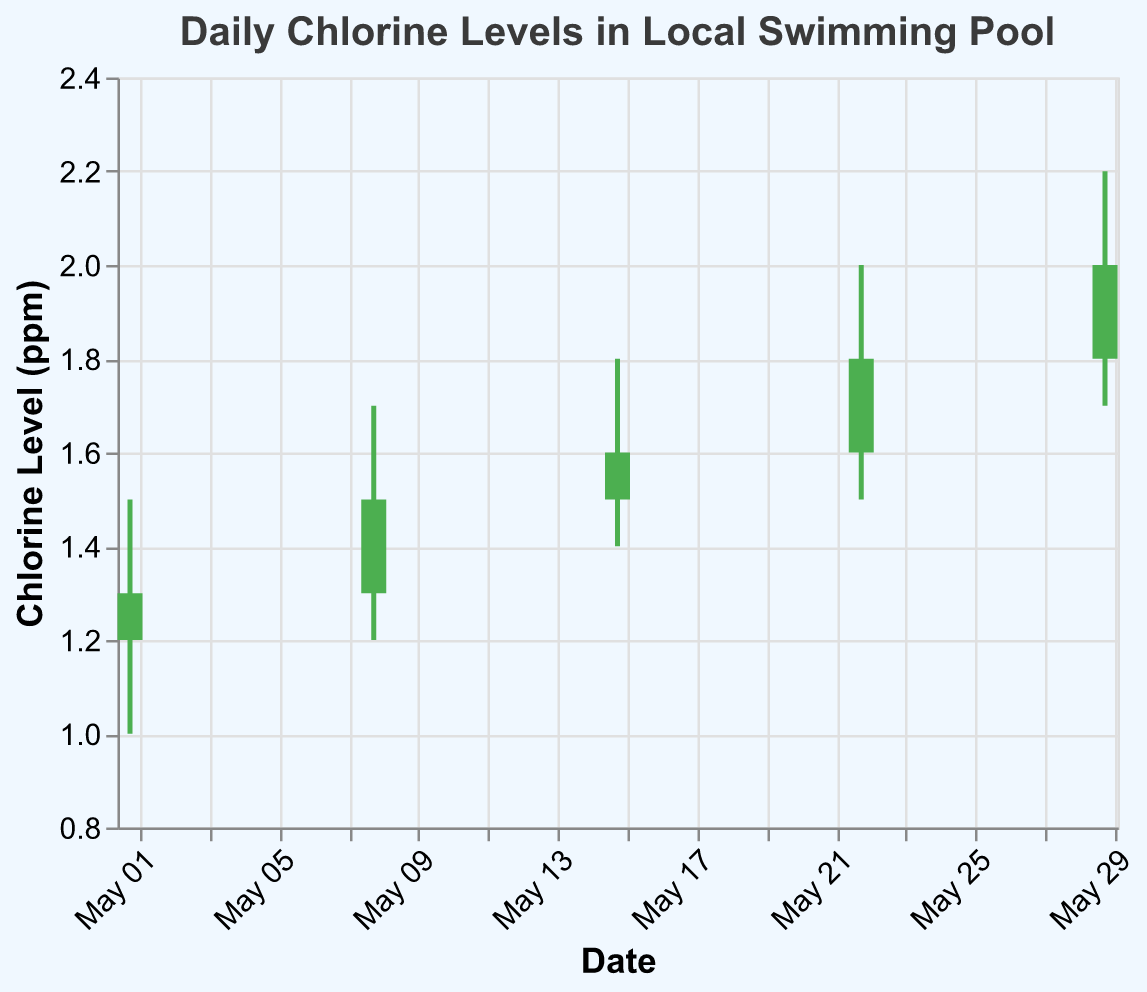What is the title of the chart? The title of the chart is displayed at the top and typically summarizes what the chart is about. In this case, it reads "Daily Chlorine Levels in Local Swimming Pool".
Answer: Daily Chlorine Levels in Local Swimming Pool What is the chlorine level on May 15th? Locate the data point corresponding to the date May 15th. You can see the Open value is 1.5, the High is 1.8, the Low is 1.4, and the Close is 1.6.
Answer: Open: 1.5, High: 1.8, Low: 1.4, Close: 1.6 Which date has the highest closing chlorine level? Examine the Close values for each date and identify the highest one. The highest Close value is 2.0, which occurs on May 29th.
Answer: May 29 Did the chlorine level increase or decrease on May 22nd? Compare the Open and Close values for May 22nd. If Close is higher than Open, it increased; otherwise, it decreased. For May 22nd, the Open is 1.6, and the Close is 1.8, showing an increase.
Answer: Increase On which dates is the opening chlorine level lower than the closing chlorine level? Check each date to see if the Open value is less than the Close value. These dates are May 1st, May 8th, May 15th, May 22nd, and May 29th.
Answer: May 1, May 8, May 15, May 22, May 29 What is the range (difference between the high and low) of the chlorine level on May 8th? Subtract the Low value from the High value for May 8th (1.7 - 1.2).
Answer: 0.5 Which date shows the smallest difference between the highest and lowest chlorine levels? Calculate the difference between the High and Low values for each date, then identify the smallest one. May 1st has a range of 0.5, May 8th is 0.5, May 15th is 0.4, May 22nd is 0.5, and May 29th is 0.5. So, May 15th has the smallest range.
Answer: May 15 What is the average opening chlorine level over the month? Sum all the Open values (1.2 + 1.3 + 1.5 + 1.6 + 1.8) and divide by the number of dates (5). The total is 7.4, and the average is 7.4 / 5.
Answer: 1.48 Is there a general trend in the chlorine levels throughout the month? Observing the closing values from the beginning to the end of the month (1.3, 1.5, 1.6, 1.8, 2.0), it shows a general increasing trend.
Answer: Increasing 